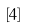<formula> <loc_0><loc_0><loc_500><loc_500>\left [ 4 \right ]</formula> 